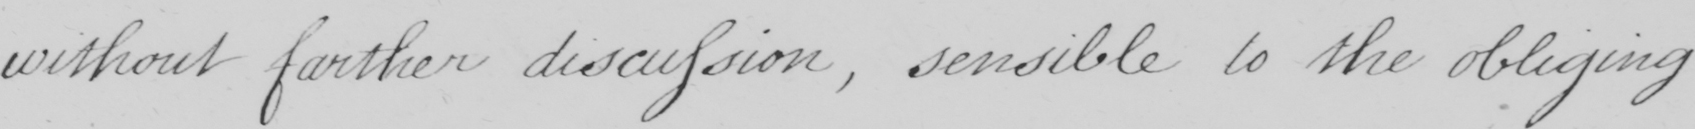Please transcribe the handwritten text in this image. without further discussion , sensible to the obliging 